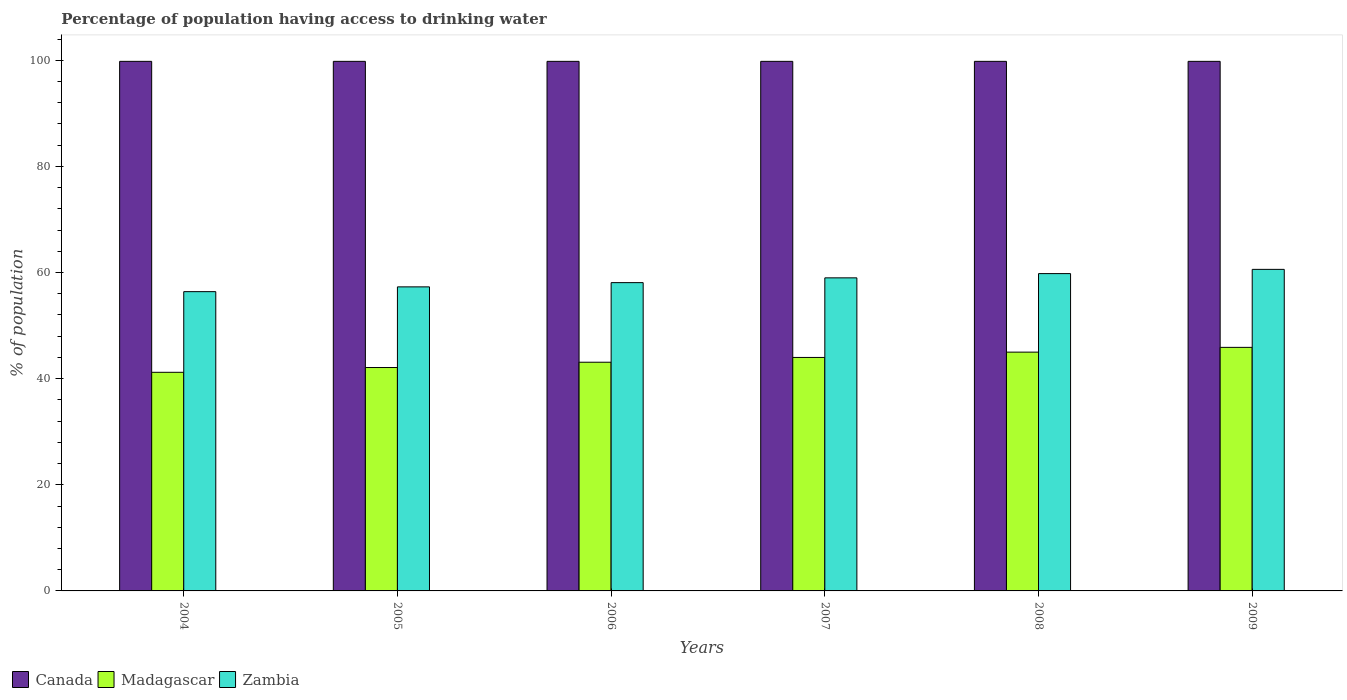How many groups of bars are there?
Offer a terse response. 6. Are the number of bars per tick equal to the number of legend labels?
Keep it short and to the point. Yes. Are the number of bars on each tick of the X-axis equal?
Your response must be concise. Yes. How many bars are there on the 3rd tick from the right?
Your answer should be compact. 3. What is the label of the 5th group of bars from the left?
Your answer should be compact. 2008. In how many cases, is the number of bars for a given year not equal to the number of legend labels?
Your response must be concise. 0. What is the percentage of population having access to drinking water in Madagascar in 2006?
Give a very brief answer. 43.1. Across all years, what is the maximum percentage of population having access to drinking water in Zambia?
Give a very brief answer. 60.6. Across all years, what is the minimum percentage of population having access to drinking water in Canada?
Your answer should be very brief. 99.8. In which year was the percentage of population having access to drinking water in Madagascar minimum?
Your answer should be compact. 2004. What is the total percentage of population having access to drinking water in Zambia in the graph?
Offer a very short reply. 351.2. What is the difference between the percentage of population having access to drinking water in Madagascar in 2004 and that in 2007?
Your answer should be compact. -2.8. What is the difference between the percentage of population having access to drinking water in Canada in 2007 and the percentage of population having access to drinking water in Madagascar in 2008?
Offer a terse response. 54.8. What is the average percentage of population having access to drinking water in Canada per year?
Your answer should be very brief. 99.8. In the year 2008, what is the difference between the percentage of population having access to drinking water in Zambia and percentage of population having access to drinking water in Madagascar?
Give a very brief answer. 14.8. What is the ratio of the percentage of population having access to drinking water in Madagascar in 2004 to that in 2008?
Offer a very short reply. 0.92. Is the percentage of population having access to drinking water in Madagascar in 2005 less than that in 2006?
Provide a succinct answer. Yes. Is the difference between the percentage of population having access to drinking water in Zambia in 2006 and 2008 greater than the difference between the percentage of population having access to drinking water in Madagascar in 2006 and 2008?
Provide a short and direct response. Yes. What is the difference between the highest and the second highest percentage of population having access to drinking water in Madagascar?
Make the answer very short. 0.9. What is the difference between the highest and the lowest percentage of population having access to drinking water in Madagascar?
Give a very brief answer. 4.7. In how many years, is the percentage of population having access to drinking water in Zambia greater than the average percentage of population having access to drinking water in Zambia taken over all years?
Provide a succinct answer. 3. What does the 2nd bar from the left in 2004 represents?
Offer a very short reply. Madagascar. Is it the case that in every year, the sum of the percentage of population having access to drinking water in Zambia and percentage of population having access to drinking water in Madagascar is greater than the percentage of population having access to drinking water in Canada?
Offer a very short reply. No. How many bars are there?
Offer a very short reply. 18. What is the difference between two consecutive major ticks on the Y-axis?
Your answer should be very brief. 20. Does the graph contain any zero values?
Give a very brief answer. No. Where does the legend appear in the graph?
Give a very brief answer. Bottom left. How are the legend labels stacked?
Your response must be concise. Horizontal. What is the title of the graph?
Ensure brevity in your answer.  Percentage of population having access to drinking water. What is the label or title of the Y-axis?
Your response must be concise. % of population. What is the % of population in Canada in 2004?
Offer a very short reply. 99.8. What is the % of population in Madagascar in 2004?
Provide a short and direct response. 41.2. What is the % of population in Zambia in 2004?
Provide a succinct answer. 56.4. What is the % of population of Canada in 2005?
Give a very brief answer. 99.8. What is the % of population of Madagascar in 2005?
Ensure brevity in your answer.  42.1. What is the % of population of Zambia in 2005?
Your answer should be compact. 57.3. What is the % of population in Canada in 2006?
Your response must be concise. 99.8. What is the % of population in Madagascar in 2006?
Make the answer very short. 43.1. What is the % of population of Zambia in 2006?
Provide a succinct answer. 58.1. What is the % of population in Canada in 2007?
Your answer should be compact. 99.8. What is the % of population in Zambia in 2007?
Your answer should be very brief. 59. What is the % of population of Canada in 2008?
Give a very brief answer. 99.8. What is the % of population of Madagascar in 2008?
Provide a succinct answer. 45. What is the % of population in Zambia in 2008?
Ensure brevity in your answer.  59.8. What is the % of population in Canada in 2009?
Your response must be concise. 99.8. What is the % of population in Madagascar in 2009?
Your answer should be very brief. 45.9. What is the % of population of Zambia in 2009?
Offer a terse response. 60.6. Across all years, what is the maximum % of population of Canada?
Keep it short and to the point. 99.8. Across all years, what is the maximum % of population in Madagascar?
Give a very brief answer. 45.9. Across all years, what is the maximum % of population in Zambia?
Make the answer very short. 60.6. Across all years, what is the minimum % of population of Canada?
Ensure brevity in your answer.  99.8. Across all years, what is the minimum % of population of Madagascar?
Provide a succinct answer. 41.2. Across all years, what is the minimum % of population in Zambia?
Make the answer very short. 56.4. What is the total % of population in Canada in the graph?
Provide a short and direct response. 598.8. What is the total % of population in Madagascar in the graph?
Ensure brevity in your answer.  261.3. What is the total % of population in Zambia in the graph?
Keep it short and to the point. 351.2. What is the difference between the % of population in Canada in 2004 and that in 2006?
Offer a very short reply. 0. What is the difference between the % of population of Canada in 2004 and that in 2007?
Your response must be concise. 0. What is the difference between the % of population in Zambia in 2004 and that in 2008?
Offer a terse response. -3.4. What is the difference between the % of population of Canada in 2004 and that in 2009?
Provide a short and direct response. 0. What is the difference between the % of population of Madagascar in 2004 and that in 2009?
Keep it short and to the point. -4.7. What is the difference between the % of population in Zambia in 2004 and that in 2009?
Ensure brevity in your answer.  -4.2. What is the difference between the % of population of Canada in 2005 and that in 2006?
Provide a succinct answer. 0. What is the difference between the % of population of Madagascar in 2005 and that in 2006?
Your answer should be compact. -1. What is the difference between the % of population in Madagascar in 2005 and that in 2007?
Offer a terse response. -1.9. What is the difference between the % of population of Zambia in 2005 and that in 2007?
Make the answer very short. -1.7. What is the difference between the % of population of Madagascar in 2005 and that in 2008?
Your answer should be very brief. -2.9. What is the difference between the % of population in Madagascar in 2006 and that in 2007?
Keep it short and to the point. -0.9. What is the difference between the % of population of Zambia in 2006 and that in 2007?
Keep it short and to the point. -0.9. What is the difference between the % of population in Canada in 2006 and that in 2009?
Your response must be concise. 0. What is the difference between the % of population in Canada in 2007 and that in 2009?
Your answer should be compact. 0. What is the difference between the % of population in Canada in 2008 and that in 2009?
Provide a short and direct response. 0. What is the difference between the % of population of Canada in 2004 and the % of population of Madagascar in 2005?
Your response must be concise. 57.7. What is the difference between the % of population in Canada in 2004 and the % of population in Zambia in 2005?
Your response must be concise. 42.5. What is the difference between the % of population in Madagascar in 2004 and the % of population in Zambia in 2005?
Your answer should be compact. -16.1. What is the difference between the % of population in Canada in 2004 and the % of population in Madagascar in 2006?
Your response must be concise. 56.7. What is the difference between the % of population of Canada in 2004 and the % of population of Zambia in 2006?
Make the answer very short. 41.7. What is the difference between the % of population of Madagascar in 2004 and the % of population of Zambia in 2006?
Keep it short and to the point. -16.9. What is the difference between the % of population of Canada in 2004 and the % of population of Madagascar in 2007?
Offer a terse response. 55.8. What is the difference between the % of population of Canada in 2004 and the % of population of Zambia in 2007?
Give a very brief answer. 40.8. What is the difference between the % of population in Madagascar in 2004 and the % of population in Zambia in 2007?
Keep it short and to the point. -17.8. What is the difference between the % of population in Canada in 2004 and the % of population in Madagascar in 2008?
Provide a short and direct response. 54.8. What is the difference between the % of population in Canada in 2004 and the % of population in Zambia in 2008?
Your answer should be very brief. 40. What is the difference between the % of population in Madagascar in 2004 and the % of population in Zambia in 2008?
Your answer should be compact. -18.6. What is the difference between the % of population in Canada in 2004 and the % of population in Madagascar in 2009?
Offer a very short reply. 53.9. What is the difference between the % of population of Canada in 2004 and the % of population of Zambia in 2009?
Give a very brief answer. 39.2. What is the difference between the % of population in Madagascar in 2004 and the % of population in Zambia in 2009?
Your answer should be compact. -19.4. What is the difference between the % of population of Canada in 2005 and the % of population of Madagascar in 2006?
Offer a very short reply. 56.7. What is the difference between the % of population in Canada in 2005 and the % of population in Zambia in 2006?
Your answer should be compact. 41.7. What is the difference between the % of population in Canada in 2005 and the % of population in Madagascar in 2007?
Your response must be concise. 55.8. What is the difference between the % of population of Canada in 2005 and the % of population of Zambia in 2007?
Provide a short and direct response. 40.8. What is the difference between the % of population of Madagascar in 2005 and the % of population of Zambia in 2007?
Make the answer very short. -16.9. What is the difference between the % of population of Canada in 2005 and the % of population of Madagascar in 2008?
Make the answer very short. 54.8. What is the difference between the % of population in Madagascar in 2005 and the % of population in Zambia in 2008?
Your response must be concise. -17.7. What is the difference between the % of population in Canada in 2005 and the % of population in Madagascar in 2009?
Your response must be concise. 53.9. What is the difference between the % of population in Canada in 2005 and the % of population in Zambia in 2009?
Keep it short and to the point. 39.2. What is the difference between the % of population in Madagascar in 2005 and the % of population in Zambia in 2009?
Keep it short and to the point. -18.5. What is the difference between the % of population of Canada in 2006 and the % of population of Madagascar in 2007?
Ensure brevity in your answer.  55.8. What is the difference between the % of population in Canada in 2006 and the % of population in Zambia in 2007?
Offer a terse response. 40.8. What is the difference between the % of population in Madagascar in 2006 and the % of population in Zambia in 2007?
Offer a terse response. -15.9. What is the difference between the % of population in Canada in 2006 and the % of population in Madagascar in 2008?
Ensure brevity in your answer.  54.8. What is the difference between the % of population of Canada in 2006 and the % of population of Zambia in 2008?
Make the answer very short. 40. What is the difference between the % of population of Madagascar in 2006 and the % of population of Zambia in 2008?
Provide a short and direct response. -16.7. What is the difference between the % of population in Canada in 2006 and the % of population in Madagascar in 2009?
Offer a terse response. 53.9. What is the difference between the % of population of Canada in 2006 and the % of population of Zambia in 2009?
Provide a short and direct response. 39.2. What is the difference between the % of population of Madagascar in 2006 and the % of population of Zambia in 2009?
Your response must be concise. -17.5. What is the difference between the % of population in Canada in 2007 and the % of population in Madagascar in 2008?
Your answer should be compact. 54.8. What is the difference between the % of population of Madagascar in 2007 and the % of population of Zambia in 2008?
Offer a terse response. -15.8. What is the difference between the % of population of Canada in 2007 and the % of population of Madagascar in 2009?
Your response must be concise. 53.9. What is the difference between the % of population in Canada in 2007 and the % of population in Zambia in 2009?
Offer a terse response. 39.2. What is the difference between the % of population in Madagascar in 2007 and the % of population in Zambia in 2009?
Ensure brevity in your answer.  -16.6. What is the difference between the % of population in Canada in 2008 and the % of population in Madagascar in 2009?
Your answer should be compact. 53.9. What is the difference between the % of population of Canada in 2008 and the % of population of Zambia in 2009?
Give a very brief answer. 39.2. What is the difference between the % of population in Madagascar in 2008 and the % of population in Zambia in 2009?
Make the answer very short. -15.6. What is the average % of population of Canada per year?
Provide a short and direct response. 99.8. What is the average % of population in Madagascar per year?
Your answer should be compact. 43.55. What is the average % of population of Zambia per year?
Your answer should be compact. 58.53. In the year 2004, what is the difference between the % of population of Canada and % of population of Madagascar?
Offer a very short reply. 58.6. In the year 2004, what is the difference between the % of population of Canada and % of population of Zambia?
Provide a short and direct response. 43.4. In the year 2004, what is the difference between the % of population in Madagascar and % of population in Zambia?
Provide a succinct answer. -15.2. In the year 2005, what is the difference between the % of population of Canada and % of population of Madagascar?
Offer a terse response. 57.7. In the year 2005, what is the difference between the % of population of Canada and % of population of Zambia?
Keep it short and to the point. 42.5. In the year 2005, what is the difference between the % of population of Madagascar and % of population of Zambia?
Your answer should be very brief. -15.2. In the year 2006, what is the difference between the % of population of Canada and % of population of Madagascar?
Offer a terse response. 56.7. In the year 2006, what is the difference between the % of population in Canada and % of population in Zambia?
Make the answer very short. 41.7. In the year 2007, what is the difference between the % of population in Canada and % of population in Madagascar?
Offer a very short reply. 55.8. In the year 2007, what is the difference between the % of population in Canada and % of population in Zambia?
Your answer should be very brief. 40.8. In the year 2007, what is the difference between the % of population in Madagascar and % of population in Zambia?
Your response must be concise. -15. In the year 2008, what is the difference between the % of population of Canada and % of population of Madagascar?
Make the answer very short. 54.8. In the year 2008, what is the difference between the % of population of Canada and % of population of Zambia?
Ensure brevity in your answer.  40. In the year 2008, what is the difference between the % of population in Madagascar and % of population in Zambia?
Your answer should be compact. -14.8. In the year 2009, what is the difference between the % of population in Canada and % of population in Madagascar?
Provide a succinct answer. 53.9. In the year 2009, what is the difference between the % of population in Canada and % of population in Zambia?
Your response must be concise. 39.2. In the year 2009, what is the difference between the % of population in Madagascar and % of population in Zambia?
Your response must be concise. -14.7. What is the ratio of the % of population in Canada in 2004 to that in 2005?
Provide a short and direct response. 1. What is the ratio of the % of population of Madagascar in 2004 to that in 2005?
Your response must be concise. 0.98. What is the ratio of the % of population in Zambia in 2004 to that in 2005?
Offer a very short reply. 0.98. What is the ratio of the % of population of Canada in 2004 to that in 2006?
Your answer should be compact. 1. What is the ratio of the % of population in Madagascar in 2004 to that in 2006?
Provide a succinct answer. 0.96. What is the ratio of the % of population in Zambia in 2004 to that in 2006?
Your response must be concise. 0.97. What is the ratio of the % of population of Canada in 2004 to that in 2007?
Offer a terse response. 1. What is the ratio of the % of population in Madagascar in 2004 to that in 2007?
Your answer should be compact. 0.94. What is the ratio of the % of population in Zambia in 2004 to that in 2007?
Provide a short and direct response. 0.96. What is the ratio of the % of population in Canada in 2004 to that in 2008?
Provide a short and direct response. 1. What is the ratio of the % of population of Madagascar in 2004 to that in 2008?
Keep it short and to the point. 0.92. What is the ratio of the % of population in Zambia in 2004 to that in 2008?
Offer a terse response. 0.94. What is the ratio of the % of population of Canada in 2004 to that in 2009?
Give a very brief answer. 1. What is the ratio of the % of population in Madagascar in 2004 to that in 2009?
Offer a terse response. 0.9. What is the ratio of the % of population of Zambia in 2004 to that in 2009?
Keep it short and to the point. 0.93. What is the ratio of the % of population of Canada in 2005 to that in 2006?
Provide a succinct answer. 1. What is the ratio of the % of population of Madagascar in 2005 to that in 2006?
Give a very brief answer. 0.98. What is the ratio of the % of population of Zambia in 2005 to that in 2006?
Your answer should be very brief. 0.99. What is the ratio of the % of population in Madagascar in 2005 to that in 2007?
Make the answer very short. 0.96. What is the ratio of the % of population of Zambia in 2005 to that in 2007?
Your answer should be compact. 0.97. What is the ratio of the % of population of Madagascar in 2005 to that in 2008?
Offer a terse response. 0.94. What is the ratio of the % of population of Zambia in 2005 to that in 2008?
Offer a terse response. 0.96. What is the ratio of the % of population of Canada in 2005 to that in 2009?
Your answer should be very brief. 1. What is the ratio of the % of population of Madagascar in 2005 to that in 2009?
Your response must be concise. 0.92. What is the ratio of the % of population of Zambia in 2005 to that in 2009?
Ensure brevity in your answer.  0.95. What is the ratio of the % of population in Canada in 2006 to that in 2007?
Your answer should be compact. 1. What is the ratio of the % of population of Madagascar in 2006 to that in 2007?
Provide a short and direct response. 0.98. What is the ratio of the % of population of Zambia in 2006 to that in 2007?
Provide a succinct answer. 0.98. What is the ratio of the % of population in Madagascar in 2006 to that in 2008?
Provide a short and direct response. 0.96. What is the ratio of the % of population in Zambia in 2006 to that in 2008?
Provide a succinct answer. 0.97. What is the ratio of the % of population in Madagascar in 2006 to that in 2009?
Provide a succinct answer. 0.94. What is the ratio of the % of population in Zambia in 2006 to that in 2009?
Your response must be concise. 0.96. What is the ratio of the % of population in Canada in 2007 to that in 2008?
Provide a succinct answer. 1. What is the ratio of the % of population of Madagascar in 2007 to that in 2008?
Provide a succinct answer. 0.98. What is the ratio of the % of population in Zambia in 2007 to that in 2008?
Ensure brevity in your answer.  0.99. What is the ratio of the % of population in Canada in 2007 to that in 2009?
Keep it short and to the point. 1. What is the ratio of the % of population in Madagascar in 2007 to that in 2009?
Make the answer very short. 0.96. What is the ratio of the % of population of Zambia in 2007 to that in 2009?
Provide a succinct answer. 0.97. What is the ratio of the % of population in Canada in 2008 to that in 2009?
Ensure brevity in your answer.  1. What is the ratio of the % of population of Madagascar in 2008 to that in 2009?
Your answer should be very brief. 0.98. What is the difference between the highest and the second highest % of population in Canada?
Provide a short and direct response. 0. What is the difference between the highest and the second highest % of population of Zambia?
Your response must be concise. 0.8. 